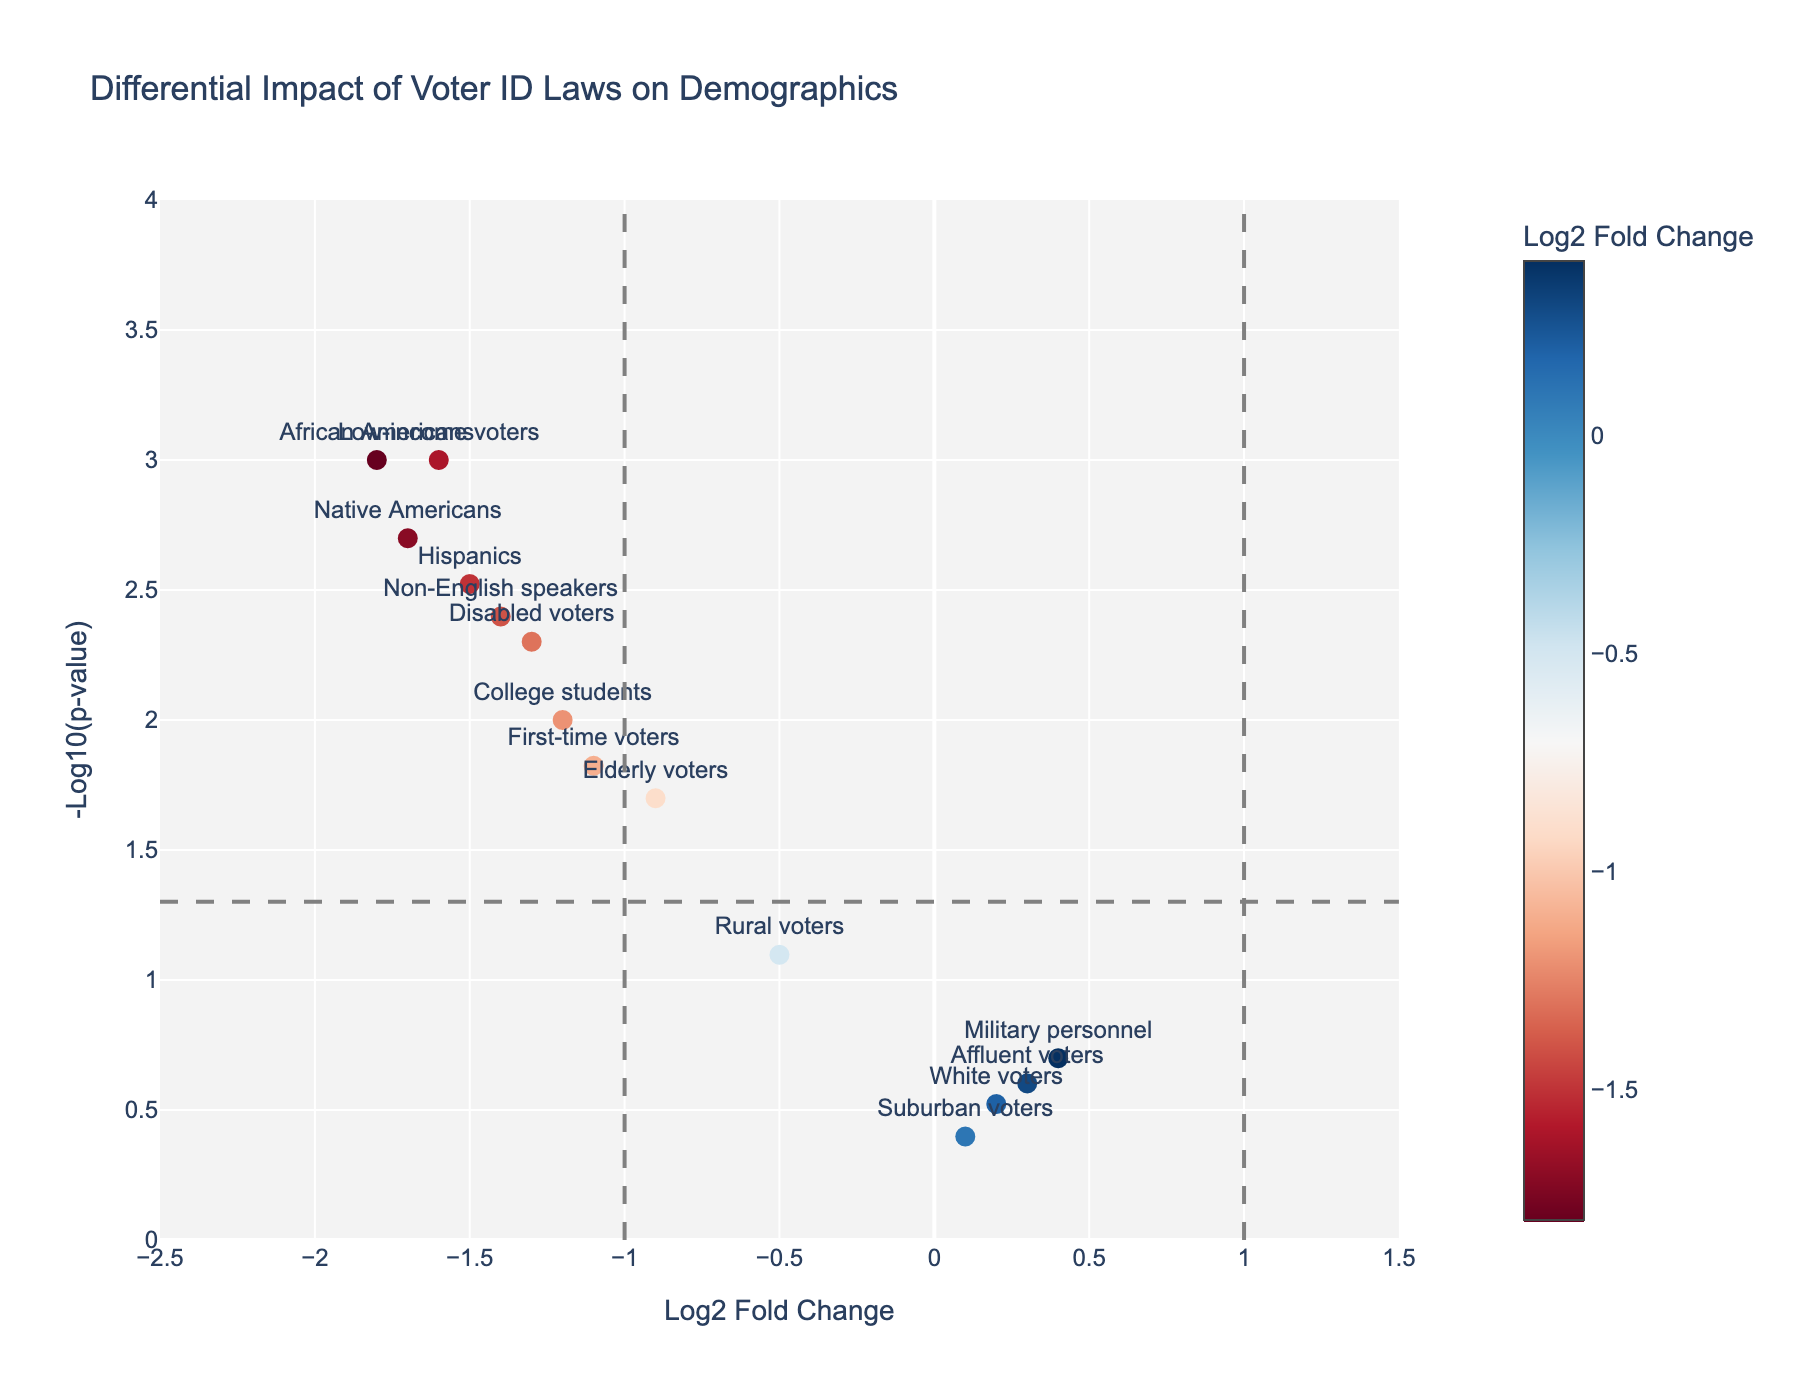What is the title of the figure? The title is typically found at the top of the figure and describes what the plot is about.
Answer: Differential Impact of Voter ID Laws on Demographics Which demographic group has the lowest log2 fold change? Examine the x-axis, which represents the log2 fold change, and find the group with the most negative value.
Answer: African Americans Which groups are significantly affected by the voter ID laws at a p-value threshold of 0.05? Identify groups above the horizontal dashed line and below the log2 fold change thresholds of -1 and 1. This indicates significance.
Answer: African Americans, Hispanics, Native Americans, Low-income voters, Disabled voters, Non-English speakers, First-time voters What is the log2 fold change and p-value for college students? Look at the point labeled "College students" and read off its coordinates from the axes.
Answer: Log2 fold change: -1.2, p-value: 0.01 Which demographic group has the highest -log10(p-value)? Examine the y-axis representing -log10(p-value). Find the group that is highest on this axis.
Answer: African Americans Compare the impact on first-time voters and elderly voters. Which group shows a bigger fold change? Compare the x-axis values (log2 fold changes) for both groups. A more negative value indicates a larger change.
Answer: First-time voters Which groups have a log2 fold change greater than -1 but less than 0? Examine the x-axis and identify groups whose values fall in the range (-1, 0).
Answer: Elderly voters, First-time voters How does the impact on suburban voters compare to rural voters in terms of log2 fold change? Look at the x-axis values for suburban and rural voters and compare them.
Answer: Rural voters are more negatively impacted How many demographic groups have a p-value less than 0.01? Identify the groups below the horizontal dashed line representing -log10(0.01). Count them.
Answer: Four groups Are there any groups with a positive log2 fold change? If so, name them. Examine the x-axis for any groups to the right of zero and list them.
Answer: White voters, Affluent voters, Suburban voters, Military personnel 